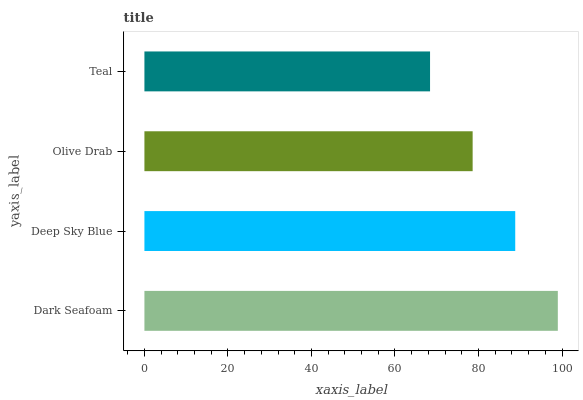Is Teal the minimum?
Answer yes or no. Yes. Is Dark Seafoam the maximum?
Answer yes or no. Yes. Is Deep Sky Blue the minimum?
Answer yes or no. No. Is Deep Sky Blue the maximum?
Answer yes or no. No. Is Dark Seafoam greater than Deep Sky Blue?
Answer yes or no. Yes. Is Deep Sky Blue less than Dark Seafoam?
Answer yes or no. Yes. Is Deep Sky Blue greater than Dark Seafoam?
Answer yes or no. No. Is Dark Seafoam less than Deep Sky Blue?
Answer yes or no. No. Is Deep Sky Blue the high median?
Answer yes or no. Yes. Is Olive Drab the low median?
Answer yes or no. Yes. Is Dark Seafoam the high median?
Answer yes or no. No. Is Teal the low median?
Answer yes or no. No. 